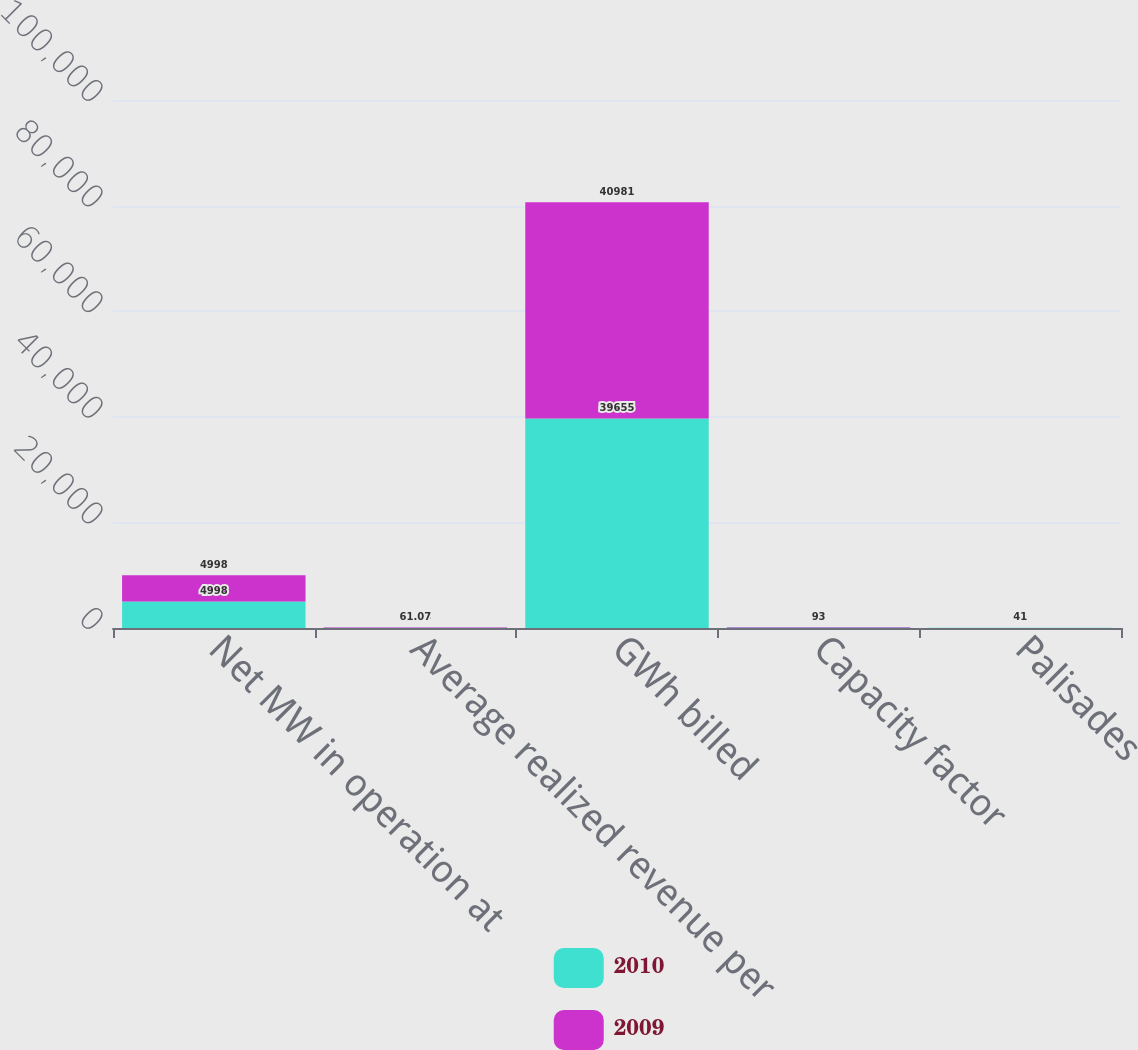Convert chart. <chart><loc_0><loc_0><loc_500><loc_500><stacked_bar_chart><ecel><fcel>Net MW in operation at<fcel>Average realized revenue per<fcel>GWh billed<fcel>Capacity factor<fcel>Palisades<nl><fcel>2010<fcel>4998<fcel>59.16<fcel>39655<fcel>90<fcel>26<nl><fcel>2009<fcel>4998<fcel>61.07<fcel>40981<fcel>93<fcel>41<nl></chart> 